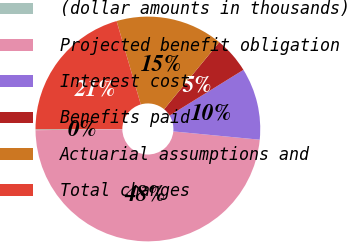Convert chart. <chart><loc_0><loc_0><loc_500><loc_500><pie_chart><fcel>(dollar amounts in thousands)<fcel>Projected benefit obligation<fcel>Interest cost<fcel>Benefits paid<fcel>Actuarial assumptions and<fcel>Total changes<nl><fcel>0.13%<fcel>48.31%<fcel>10.34%<fcel>5.23%<fcel>15.44%<fcel>20.55%<nl></chart> 